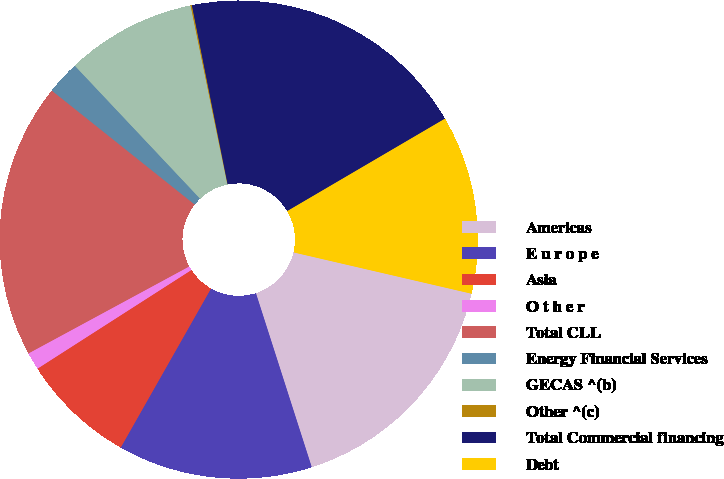Convert chart. <chart><loc_0><loc_0><loc_500><loc_500><pie_chart><fcel>Americas<fcel>E u r o p e<fcel>Asia<fcel>O t h e r<fcel>Total CLL<fcel>Energy Financial Services<fcel>GECAS ^(b)<fcel>Other ^(c)<fcel>Total Commercial financing<fcel>Debt<nl><fcel>16.43%<fcel>13.16%<fcel>7.71%<fcel>1.18%<fcel>18.61%<fcel>2.26%<fcel>8.8%<fcel>0.09%<fcel>19.7%<fcel>12.07%<nl></chart> 